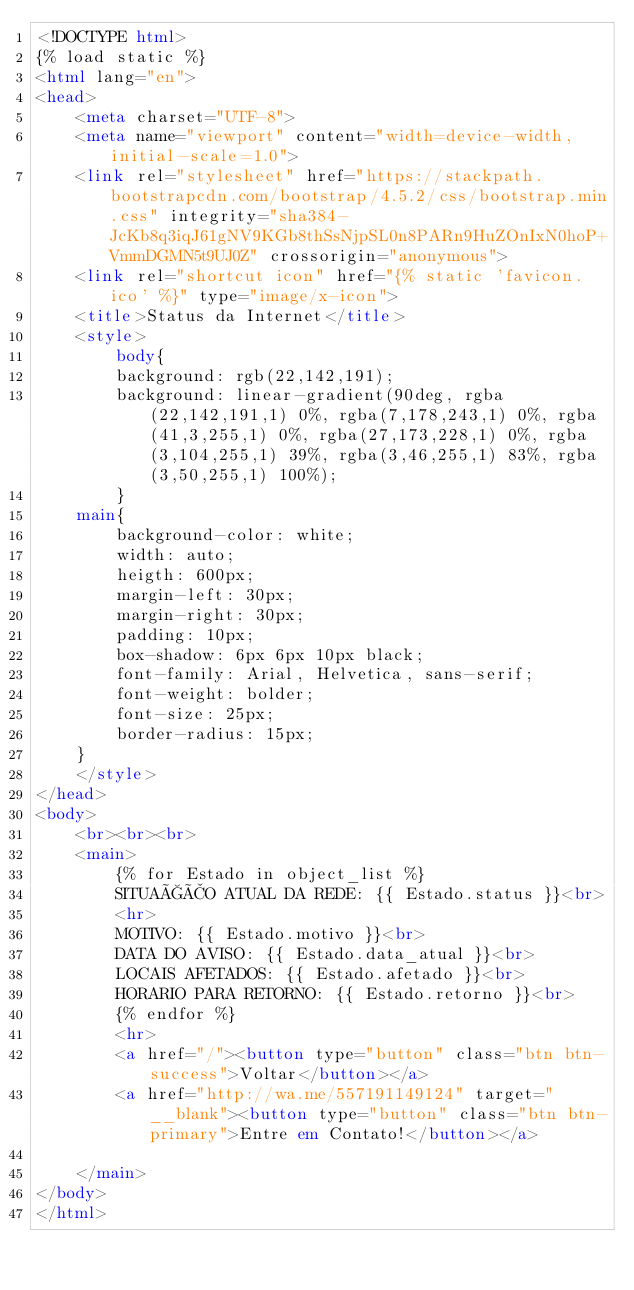<code> <loc_0><loc_0><loc_500><loc_500><_HTML_><!DOCTYPE html>
{% load static %}
<html lang="en">
<head>
    <meta charset="UTF-8">
    <meta name="viewport" content="width=device-width, initial-scale=1.0">
    <link rel="stylesheet" href="https://stackpath.bootstrapcdn.com/bootstrap/4.5.2/css/bootstrap.min.css" integrity="sha384-JcKb8q3iqJ61gNV9KGb8thSsNjpSL0n8PARn9HuZOnIxN0hoP+VmmDGMN5t9UJ0Z" crossorigin="anonymous">
    <link rel="shortcut icon" href="{% static 'favicon.ico' %}" type="image/x-icon">
    <title>Status da Internet</title>
    <style>
        body{
        background: rgb(22,142,191);
        background: linear-gradient(90deg, rgba(22,142,191,1) 0%, rgba(7,178,243,1) 0%, rgba(41,3,255,1) 0%, rgba(27,173,228,1) 0%, rgba(3,104,255,1) 39%, rgba(3,46,255,1) 83%, rgba(3,50,255,1) 100%);
        }
    main{
        background-color: white;
        width: auto;
        heigth: 600px;
        margin-left: 30px;
        margin-right: 30px;
        padding: 10px;
        box-shadow: 6px 6px 10px black;
        font-family: Arial, Helvetica, sans-serif;
        font-weight: bolder;
        font-size: 25px;
        border-radius: 15px;
    }
    </style>
</head>
<body>
    <br><br><br>
    <main>
        {% for Estado in object_list %}
        SITUAÇÃO ATUAL DA REDE: {{ Estado.status }}<br>
        <hr>
        MOTIVO: {{ Estado.motivo }}<br>
        DATA DO AVISO: {{ Estado.data_atual }}<br>
        LOCAIS AFETADOS: {{ Estado.afetado }}<br>
        HORARIO PARA RETORNO: {{ Estado.retorno }}<br>
        {% endfor %}
        <hr>
        <a href="/"><button type="button" class="btn btn-success">Voltar</button></a>
        <a href="http://wa.me/557191149124" target="__blank"><button type="button" class="btn btn-primary">Entre em Contato!</button></a>
        
    </main>
</body>
</html></code> 